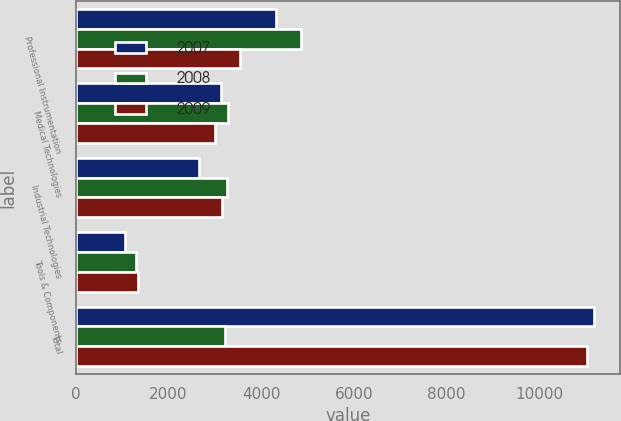Convert chart. <chart><loc_0><loc_0><loc_500><loc_500><stacked_bar_chart><ecel><fcel>Professional Instrumentation<fcel>Medical Technologies<fcel>Industrial Technologies<fcel>Tools & Components<fcel>Total<nl><fcel>2007<fcel>4330.7<fcel>3141.9<fcel>2658<fcel>1054.3<fcel>11184.9<nl><fcel>2008<fcel>4860.8<fcel>3277<fcel>3265.5<fcel>1294.2<fcel>3209.45<nl><fcel>2009<fcel>3537.9<fcel>2998<fcel>3153.4<fcel>1336.6<fcel>11025.9<nl></chart> 